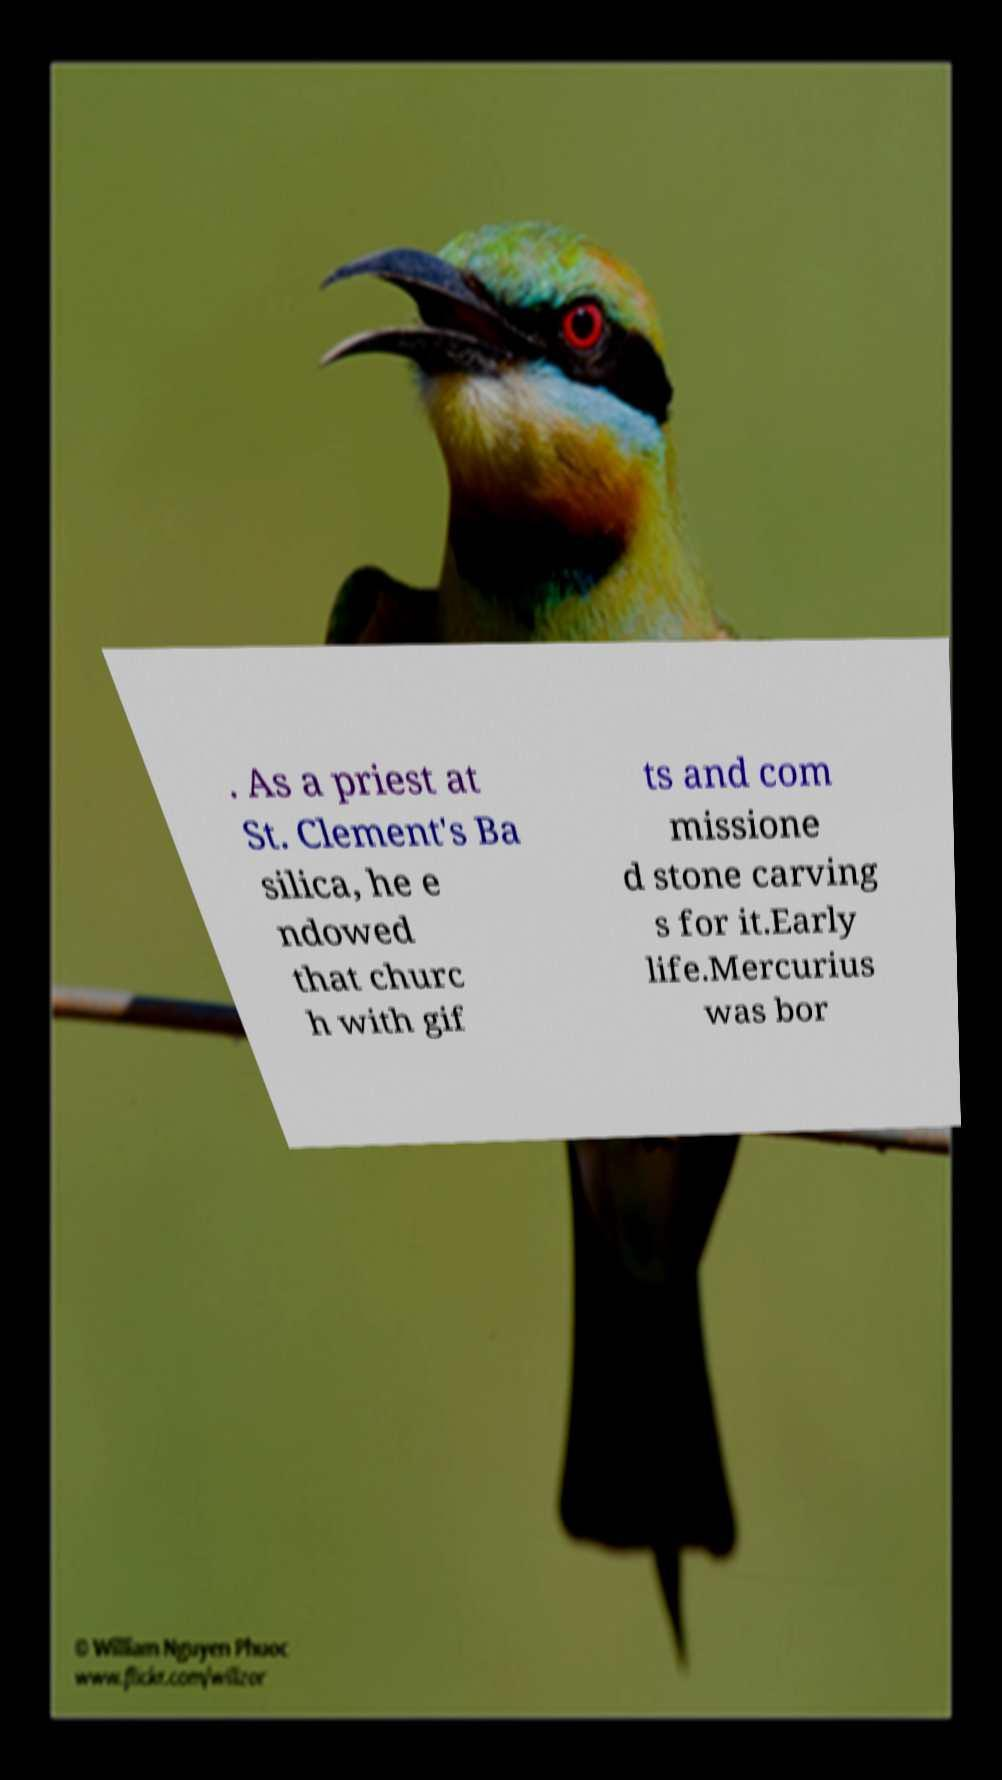Could you extract and type out the text from this image? . As a priest at St. Clement's Ba silica, he e ndowed that churc h with gif ts and com missione d stone carving s for it.Early life.Mercurius was bor 